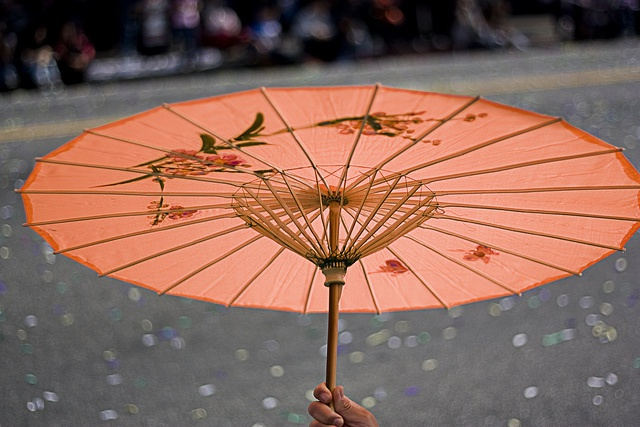Describe the objects in this image and their specific colors. I can see umbrella in black, salmon, and brown tones and people in black, brown, maroon, and gray tones in this image. 